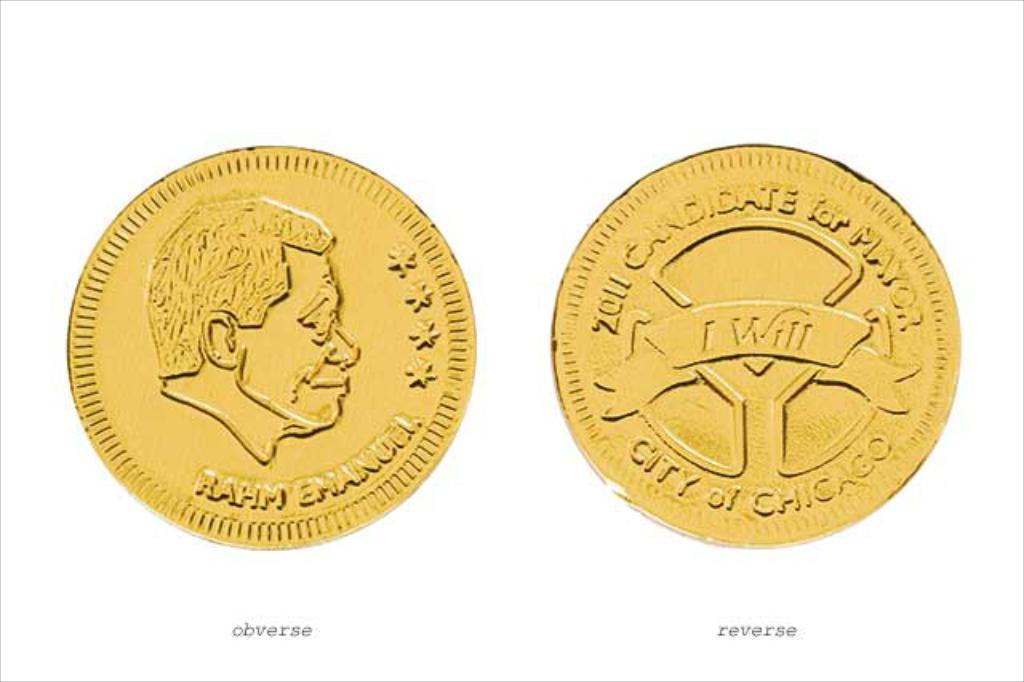<image>
Offer a succinct explanation of the picture presented. Two coins side by side with one that says CITY OF CHICAGO. 